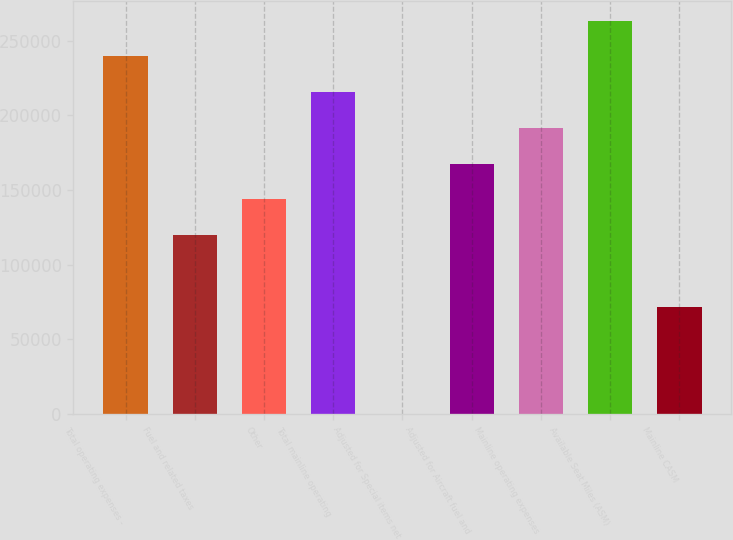Convert chart. <chart><loc_0><loc_0><loc_500><loc_500><bar_chart><fcel>Total operating expenses -<fcel>Fuel and related taxes<fcel>Other<fcel>Total mainline operating<fcel>Adjusted for Special items net<fcel>Adjusted for Aircraft fuel and<fcel>Mainline operating expenses<fcel>Available Seat Miles (ASM)<fcel>Mainline CASM<nl><fcel>239375<fcel>119688<fcel>143625<fcel>215438<fcel>0.44<fcel>167563<fcel>191500<fcel>263312<fcel>71812.8<nl></chart> 